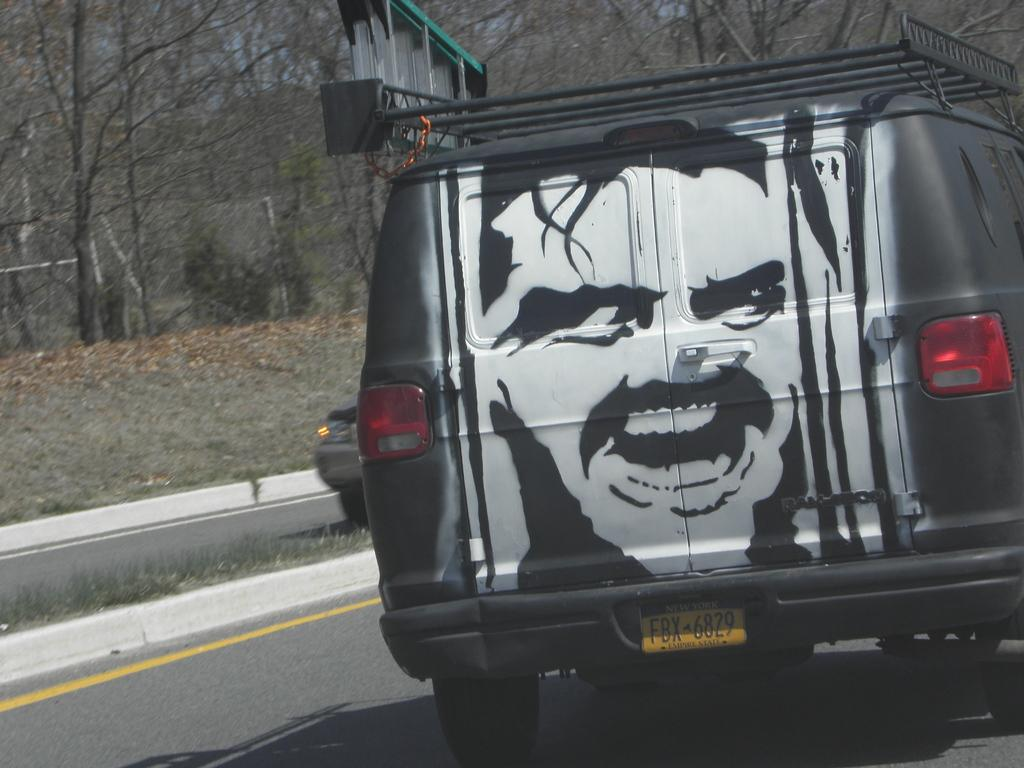What is the main subject in the center of the image? There is a vehicle in the center of the image. Where is the vehicle located? The vehicle is on the road. What can be seen in the background of the image? There are trees, plants, a road, and a car visible in the background of the image. What color is the crayon used to draw the road in the image? There is no crayon present in the image; it is a photograph of a real road. 